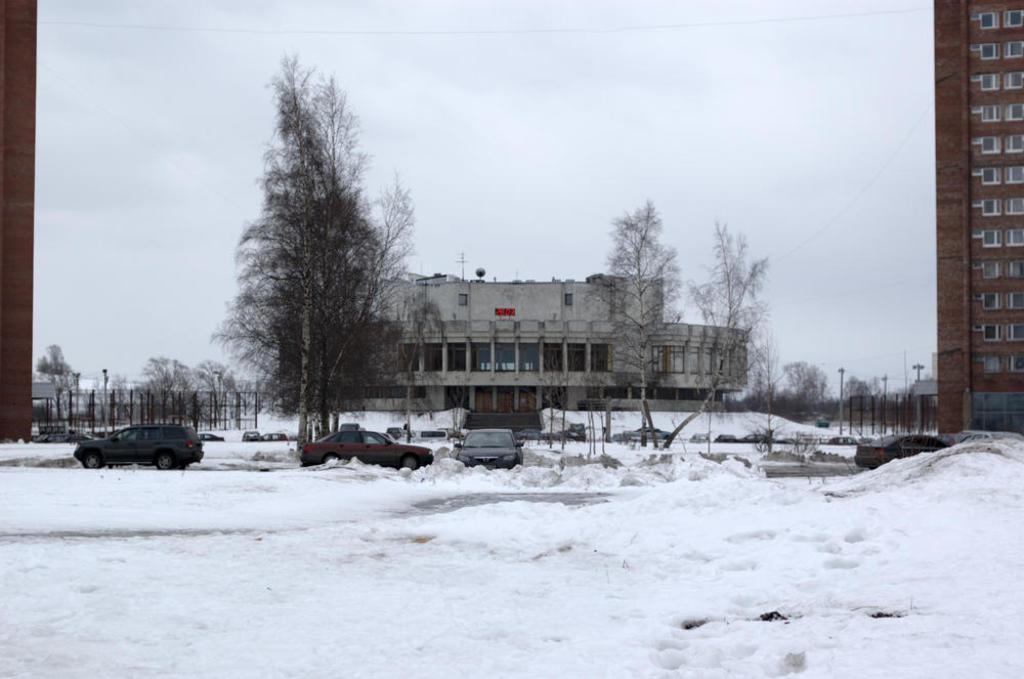Can you describe this image briefly? In this picture we can see few vehicles in the snow, in the background we can see few trees, buildings and poles. 